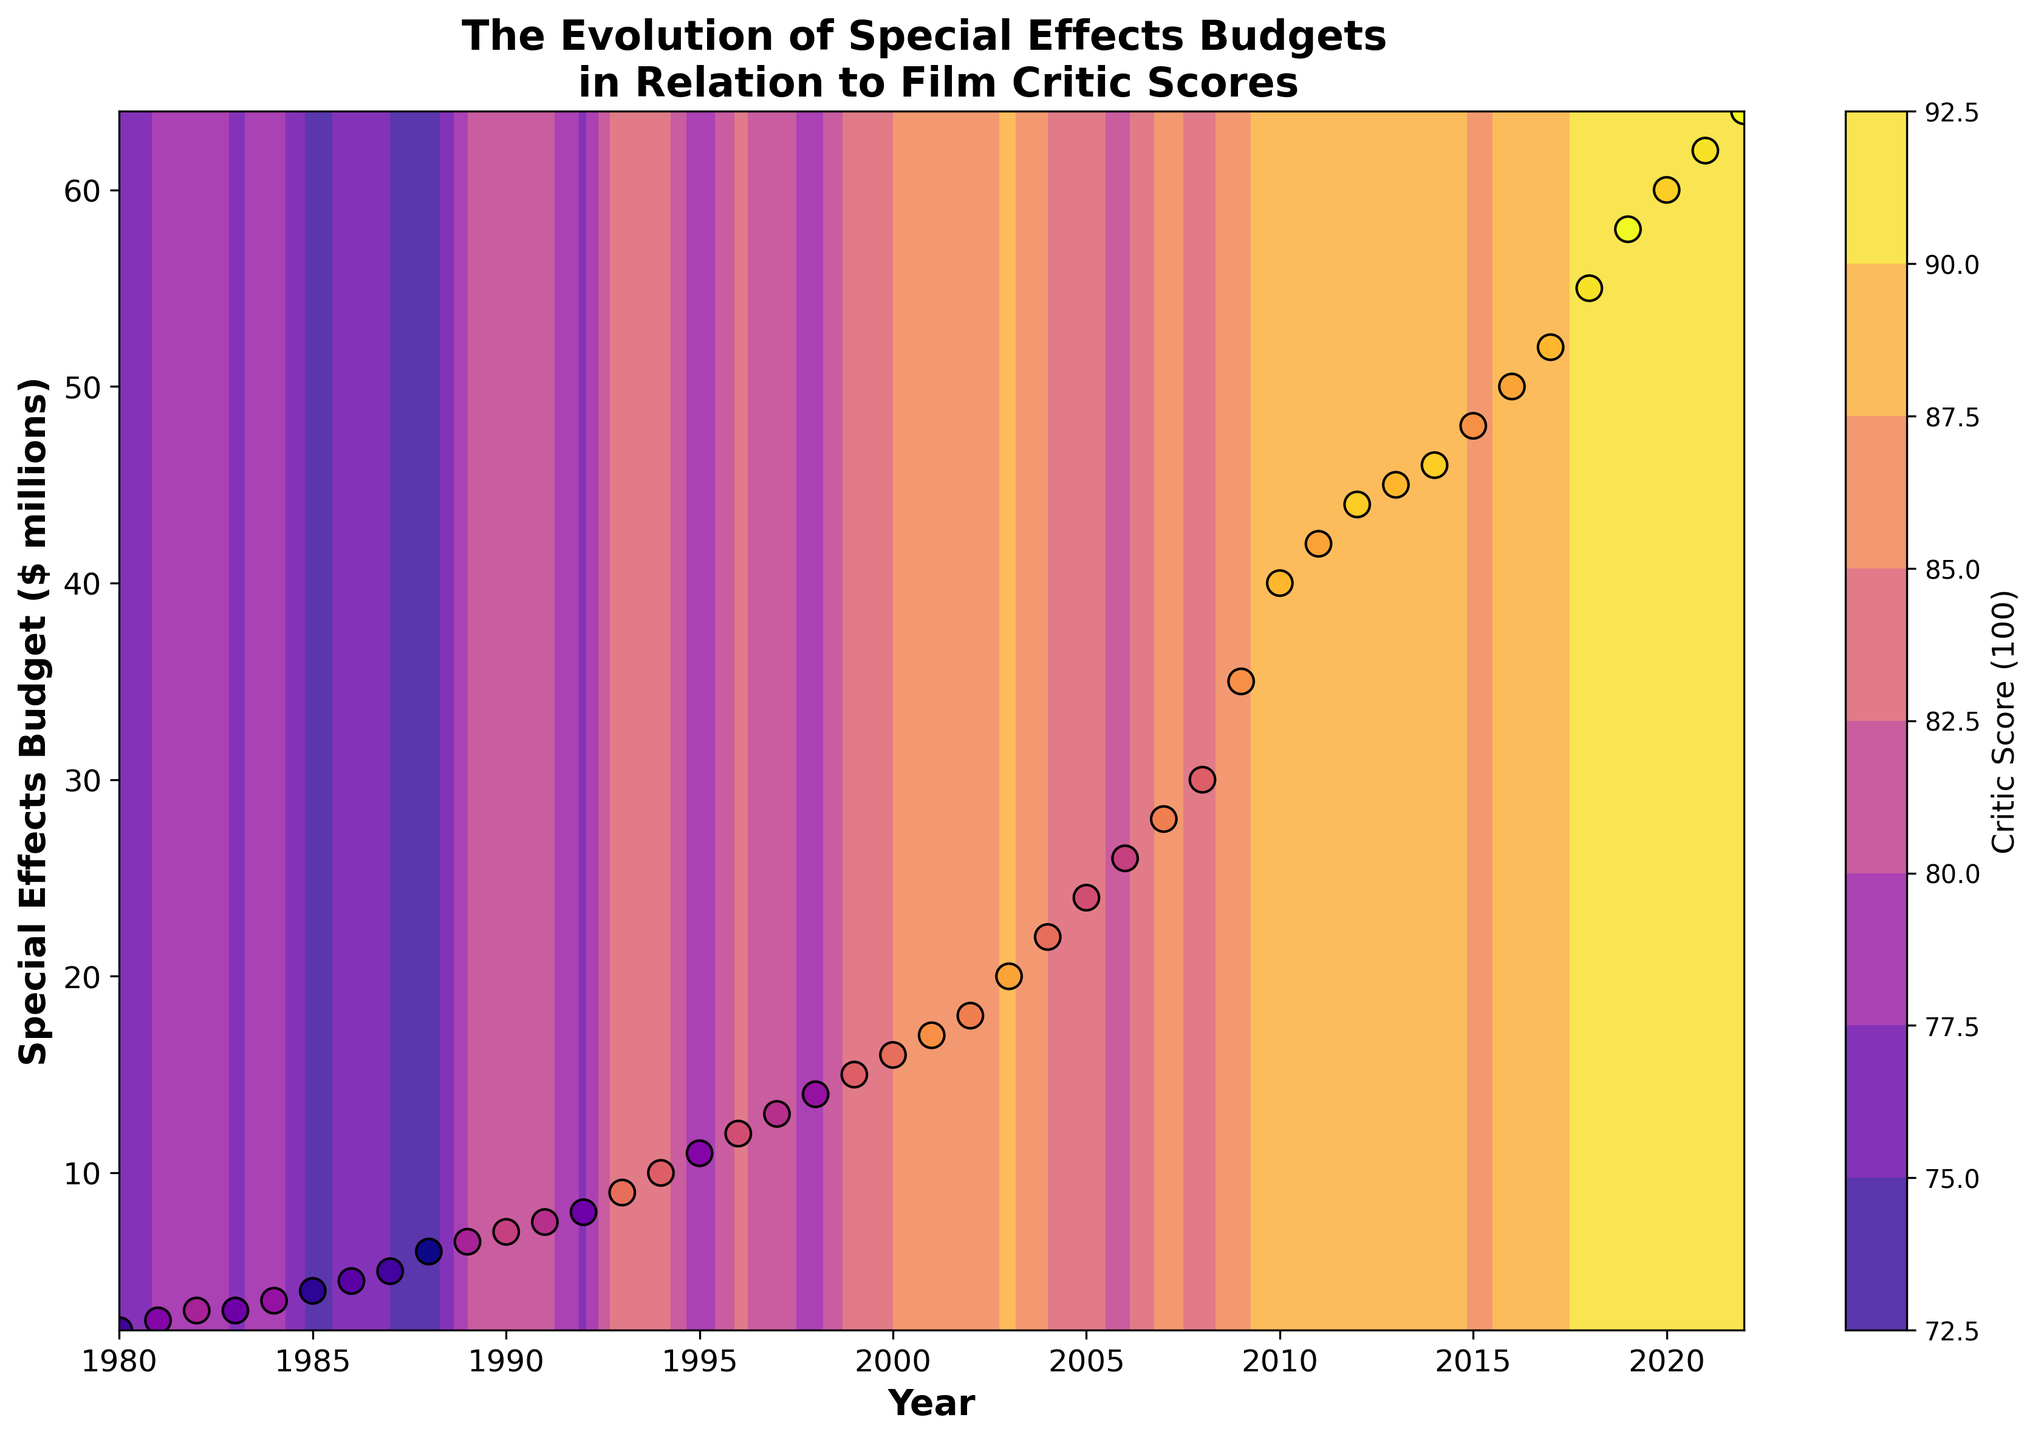what is the peak critic score on the contour plot and in which year does it occur? By reviewing the contour plot and the labeled color bar, the highest critic score can be identified easily. According to the legend, the highest score is represented by the brightest color. Upon examining the corresponding years, we find that the peak critic score is 92 and it occurs in 2019 and 2022.
Answer: 92 in 2019 and 2022 what is the trend in the special effects budget from 1980 to 2022? By analyzing the scatter points on the contour plot, it is evident that the special effects budget has been steadily increasing over the years, starting from $2 million in 1980 and reaching $64 million in 2022.
Answer: Increasing trend How do the critic scores correlate with the rise in Special Effects Budgets between 2000 and 2010? Observing the color gradient in the contour plot from 2000 to 2010, we see a mix of medium to high critic scores, indicated by the shift from lighter to darker colors. The scatter plot further reinforces that higher budgets generally align with critic scores ranging from mid 80s to upper 80s in this range.
Answer: generally positive correlation Are there any periods where the budget dramatically increases without a corresponding rise in critic scores? Examining the contour and scatter plot, from 2005 to 2011, we see a significant rise in budget from $24 million to $42 million. However, the critic scores remain relatively stable around mid-80s to upper 80s, indicating a period of no corresponding rise in critic scores.
Answer: 2005 to 2011 When did the critic score first reach 80? Evaluating the contour plot and scatter plot color variations, the critic score first reached 80 in 1982, as shown by the lighter color at that year.
Answer: 1982 Is there a visible correlation between budget and critic scores in the 1990s? From the contour plot during the 1990s, the color gradient and scatter points show that as the budgets increase, critic scores also tend to be higher, specifically from mid-70s rising into the mid-80s.
Answer: positive correlation What’s the color representing a critic score of 90 and which years are showing this score? Based on the contour plot’s color bar, the critic score of 90 is represented by one of the brighter, almost yellow colors. Reviewing the plot, the years 2012, 2014, 2018, and 2020 correspond to this score.
Answer: 2012, 2014, 2018, and 2020 